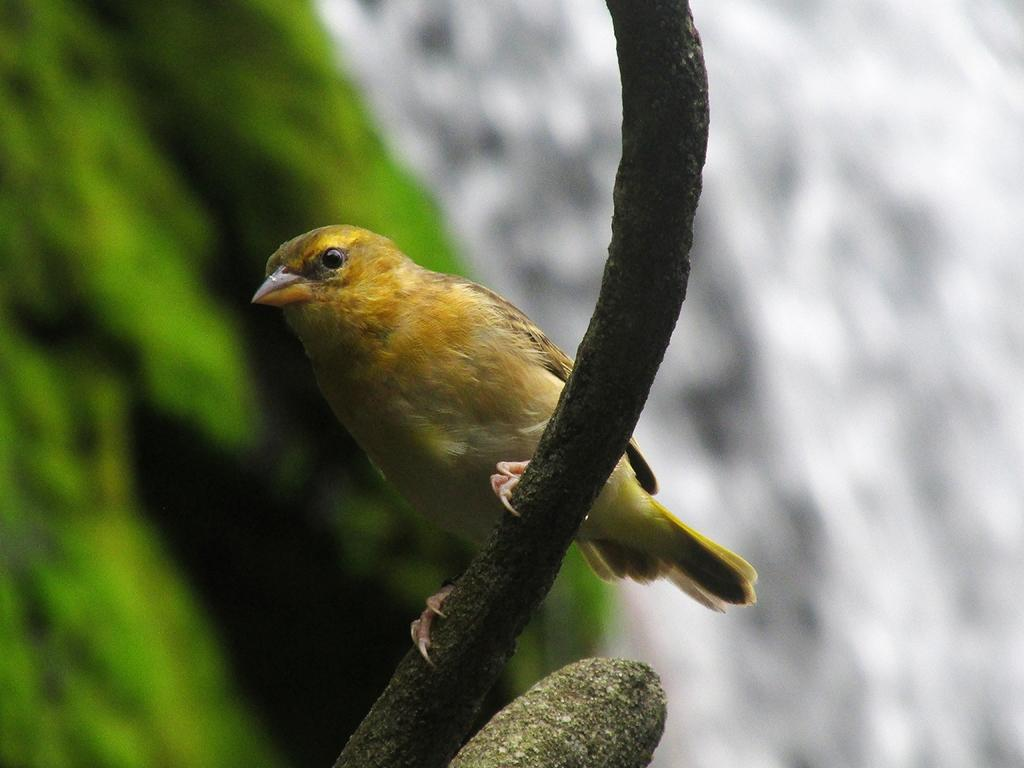What type of animal is in the image? There is a bird in the image. Can you describe the describe the colors of the bird? The bird has yellow, orange, brown, green, and black colors. What is the bird resting on in the image? The bird is on a wooden stick. How would you describe the background of the image? The background of the image is blurry. What colors are present in the background? The background colors are white, green, and black. What type of beast can be seen carrying a brick in the image? There is no beast or brick present in the image; it features a bird on a wooden stick. What items are on the list in the image? There is no list present in the image. 